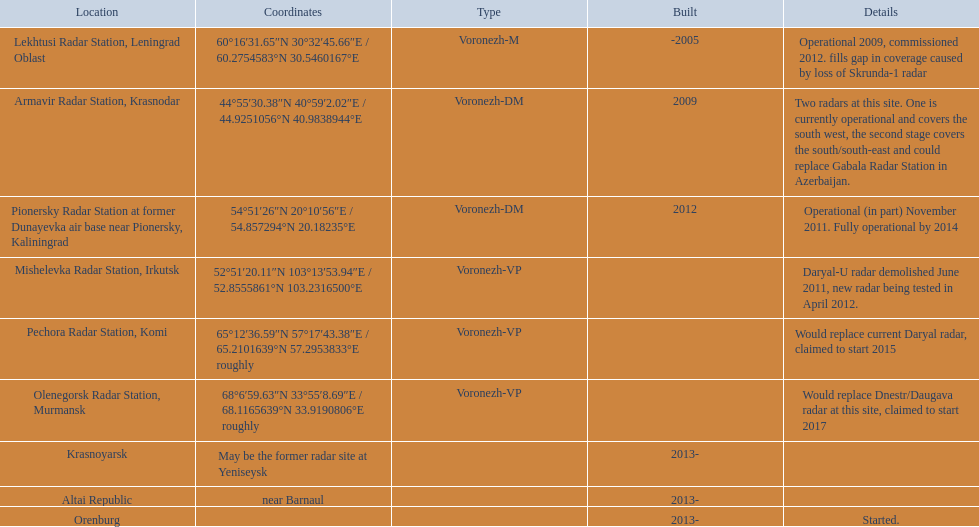In which column do the coordinates begin with 60 degrees? 60°16′31.65″N 30°32′45.66″E﻿ / ﻿60.2754583°N 30.5460167°E. What is the position within the same row as that column? Lekhtusi Radar Station, Leningrad Oblast. 